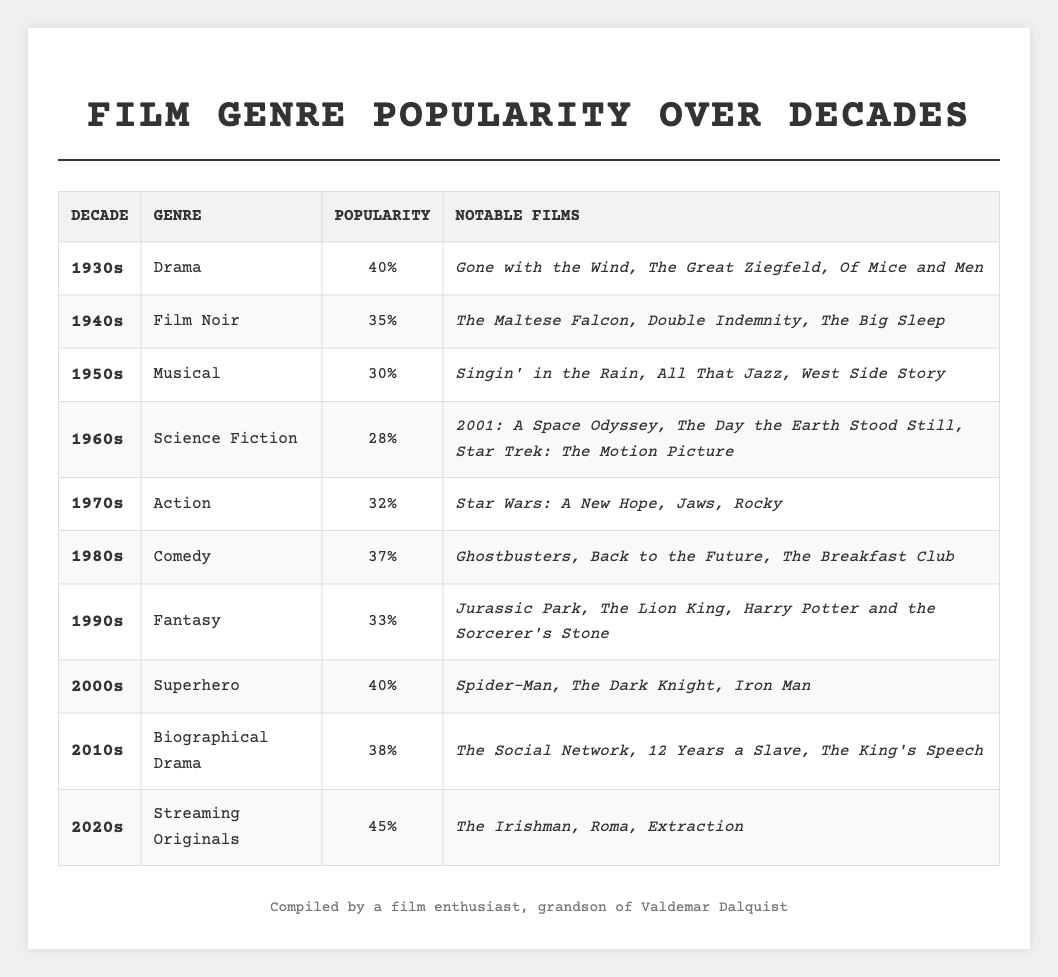What genre was the most popular in the 2020s? The table shows that the genre with the highest popularity percentage in the 2020s is Streaming Originals, with a popularity percentage of 45%.
Answer: Streaming Originals Which decade had the lowest popularity percentage and what was its genre? From the table, the 1960s had the lowest popularity percentage at 28%, and the genre was Science Fiction.
Answer: 1960s, Science Fiction What is the popularity difference between the 1940s and the 1980s? The popularity percentage in the 1940s is 35%, and in the 1980s, it's 37%. The difference is 37% - 35% = 2%.
Answer: 2% Was Comedy more popular than Action in the 1970s? The table shows that Action had a popularity percentage of 32% in the 1970s, while Comedy was popular in the 1980s with 37%. Therefore, Comedy was not present in the 1970s to compare.
Answer: No What was the average popularity of genres from the 1930s to the 1950s? The popularity percentages for these decades are 40% (1930s), 35% (1940s), and 30% (1950s). Adding them gives 40% + 35% + 30% = 105%. Dividing by 3 gives an average of 105% / 3 = 35%.
Answer: 35% Which genre saw a revival in the 2000s, matching its popularity level from the 1930s? The 1930s had a popularity of 40% for Drama, and the 2000s also had a popularity of 40% for Superhero films. Thus, both genres share this popularity level.
Answer: Superhero What decade transitioned from Film Noir to Musicals and how many percentage points did the popularity drop? The transition occurred between the 1940s (35% Film Noir) and the 1950s (30% Musical), resulting in a drop of 5 percentage points (35% - 30% = 5%).
Answer: 5 percentage points In which decade did Fantasy first appear and how popular was it? Fantasy first appeared in the 1990s, with a popularity percentage of 33%.
Answer: 1990s, 33% What are the notable films listed for the highest popularity percentage in the 2000s? The table states that notable films for the 2000s, which had 40% popularity, include Spider-Man, The Dark Knight, and Iron Man.
Answer: Spider-Man, The Dark Knight, Iron Man How many genres had a popularity percentage of 35 or higher from the 1930s to the 2010s? The genres with popularity percentages of 35 or higher from the 1930s to the 2010s are Drama (40%), Film Noir (35%), Comedy (37%), Fantasy (33%), Superhero (40%), and Biographical Drama (38%). This totals to 6 genres.
Answer: 6 